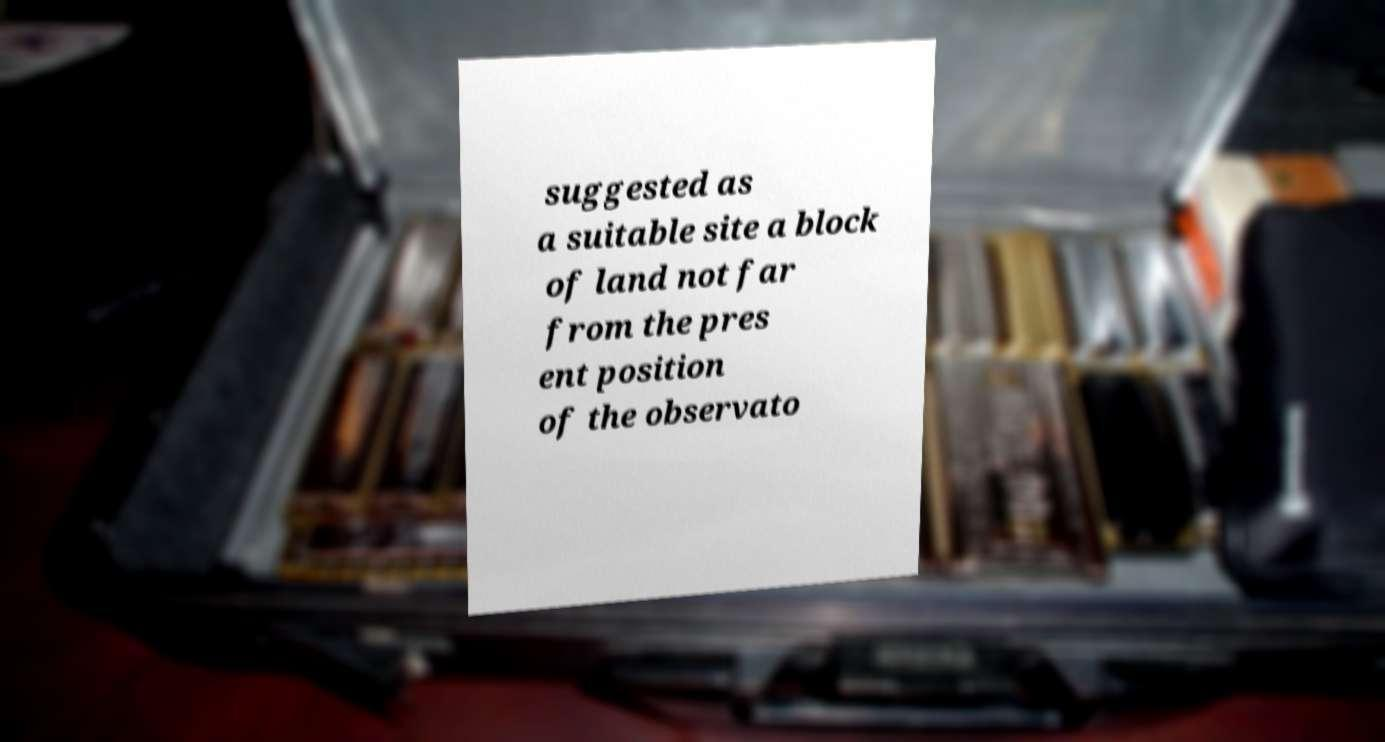Can you read and provide the text displayed in the image?This photo seems to have some interesting text. Can you extract and type it out for me? suggested as a suitable site a block of land not far from the pres ent position of the observato 